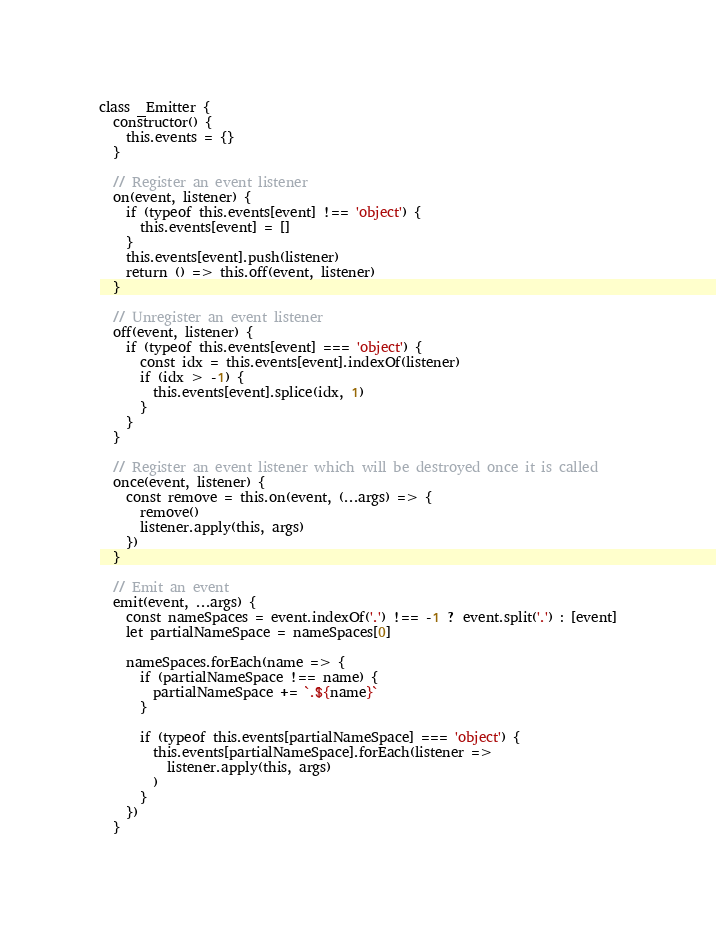<code> <loc_0><loc_0><loc_500><loc_500><_JavaScript_>class _Emitter {
  constructor() {
    this.events = {}
  }

  // Register an event listener
  on(event, listener) {
    if (typeof this.events[event] !== 'object') {
      this.events[event] = []
    }
    this.events[event].push(listener)
    return () => this.off(event, listener)
  }

  // Unregister an event listener
  off(event, listener) {
    if (typeof this.events[event] === 'object') {
      const idx = this.events[event].indexOf(listener)
      if (idx > -1) {
        this.events[event].splice(idx, 1)
      }
    }
  }

  // Register an event listener which will be destroyed once it is called
  once(event, listener) {
    const remove = this.on(event, (...args) => {
      remove()
      listener.apply(this, args)
    })
  }

  // Emit an event
  emit(event, ...args) {
    const nameSpaces = event.indexOf('.') !== -1 ? event.split('.') : [event]
    let partialNameSpace = nameSpaces[0]

    nameSpaces.forEach(name => {
      if (partialNameSpace !== name) {
        partialNameSpace += `.${name}`
      }

      if (typeof this.events[partialNameSpace] === 'object') {
        this.events[partialNameSpace].forEach(listener =>
          listener.apply(this, args)
        )
      }
    })
  }</code> 